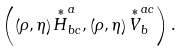<formula> <loc_0><loc_0><loc_500><loc_500>\left ( \left ( \rho , \eta \right ) \overset { \ast } { H } _ { b c } ^ { a } , \left ( \rho , \eta \right ) \overset { \ast } { V } _ { b } ^ { a c } \right ) .</formula> 